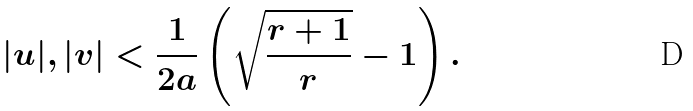<formula> <loc_0><loc_0><loc_500><loc_500>| u | , | v | < \frac { 1 } { 2 a } \left ( \sqrt { \frac { r + 1 } { r } } - 1 \right ) .</formula> 